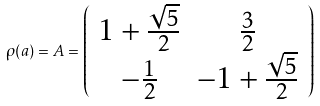Convert formula to latex. <formula><loc_0><loc_0><loc_500><loc_500>\rho ( a ) = A = \left ( \begin{array} { c c } 1 + \frac { \sqrt { 5 } } { 2 } & \frac { 3 } { 2 } \\ - \frac { 1 } { 2 } & - 1 + \frac { \sqrt { 5 } } { 2 } \end{array} \right )</formula> 